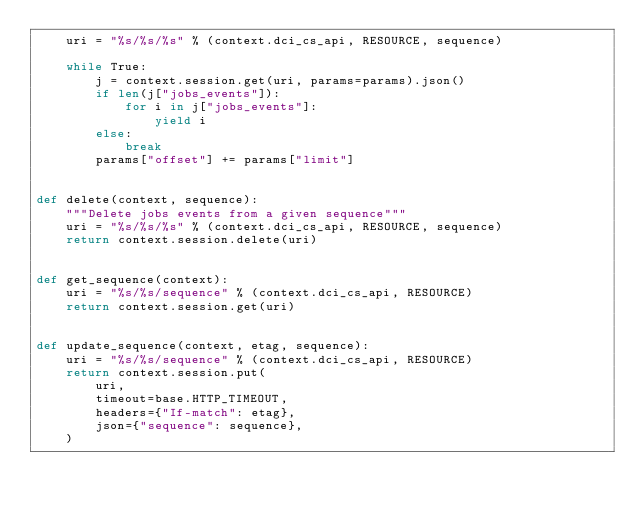<code> <loc_0><loc_0><loc_500><loc_500><_Python_>    uri = "%s/%s/%s" % (context.dci_cs_api, RESOURCE, sequence)

    while True:
        j = context.session.get(uri, params=params).json()
        if len(j["jobs_events"]):
            for i in j["jobs_events"]:
                yield i
        else:
            break
        params["offset"] += params["limit"]


def delete(context, sequence):
    """Delete jobs events from a given sequence"""
    uri = "%s/%s/%s" % (context.dci_cs_api, RESOURCE, sequence)
    return context.session.delete(uri)


def get_sequence(context):
    uri = "%s/%s/sequence" % (context.dci_cs_api, RESOURCE)
    return context.session.get(uri)


def update_sequence(context, etag, sequence):
    uri = "%s/%s/sequence" % (context.dci_cs_api, RESOURCE)
    return context.session.put(
        uri,
        timeout=base.HTTP_TIMEOUT,
        headers={"If-match": etag},
        json={"sequence": sequence},
    )
</code> 